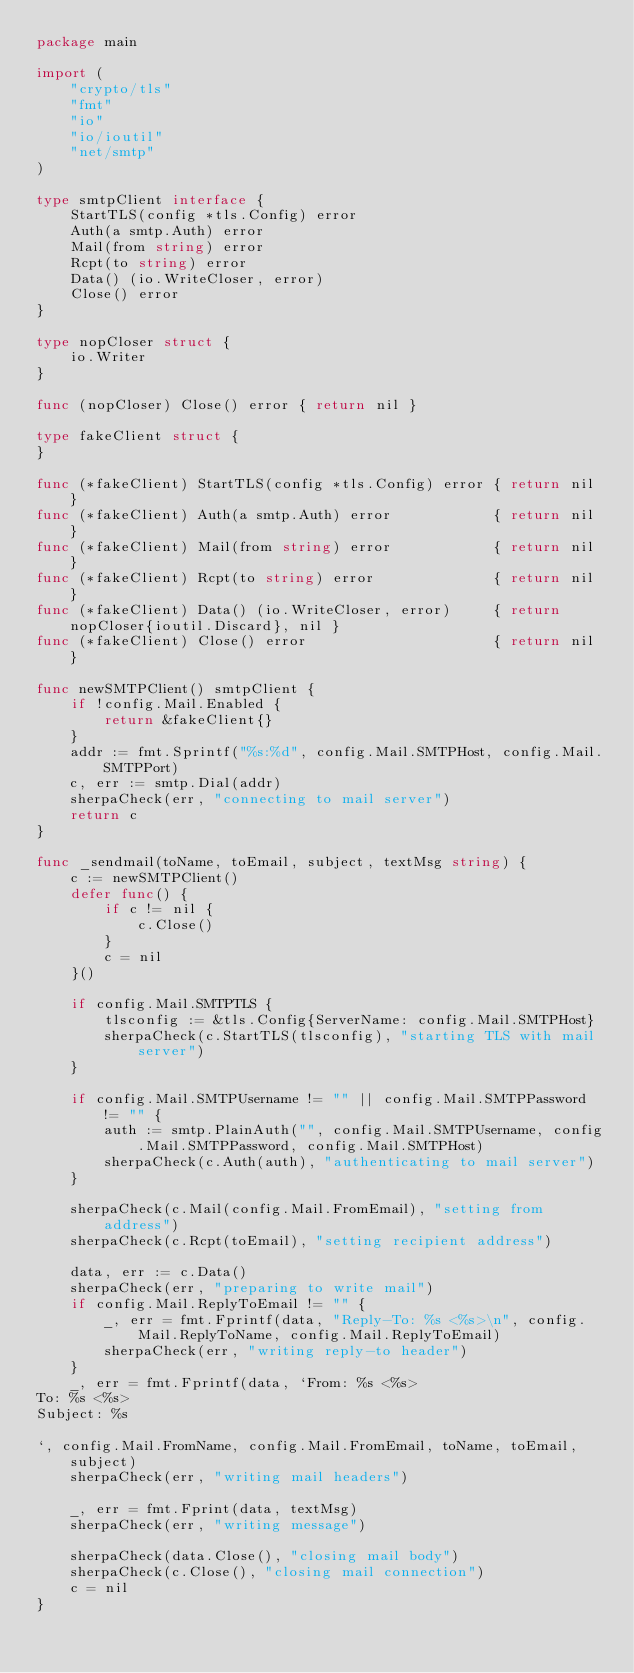Convert code to text. <code><loc_0><loc_0><loc_500><loc_500><_Go_>package main

import (
	"crypto/tls"
	"fmt"
	"io"
	"io/ioutil"
	"net/smtp"
)

type smtpClient interface {
	StartTLS(config *tls.Config) error
	Auth(a smtp.Auth) error
	Mail(from string) error
	Rcpt(to string) error
	Data() (io.WriteCloser, error)
	Close() error
}

type nopCloser struct {
	io.Writer
}

func (nopCloser) Close() error { return nil }

type fakeClient struct {
}

func (*fakeClient) StartTLS(config *tls.Config) error { return nil }
func (*fakeClient) Auth(a smtp.Auth) error            { return nil }
func (*fakeClient) Mail(from string) error            { return nil }
func (*fakeClient) Rcpt(to string) error              { return nil }
func (*fakeClient) Data() (io.WriteCloser, error)     { return nopCloser{ioutil.Discard}, nil }
func (*fakeClient) Close() error                      { return nil }

func newSMTPClient() smtpClient {
	if !config.Mail.Enabled {
		return &fakeClient{}
	}
	addr := fmt.Sprintf("%s:%d", config.Mail.SMTPHost, config.Mail.SMTPPort)
	c, err := smtp.Dial(addr)
	sherpaCheck(err, "connecting to mail server")
	return c
}

func _sendmail(toName, toEmail, subject, textMsg string) {
	c := newSMTPClient()
	defer func() {
		if c != nil {
			c.Close()
		}
		c = nil
	}()

	if config.Mail.SMTPTLS {
		tlsconfig := &tls.Config{ServerName: config.Mail.SMTPHost}
		sherpaCheck(c.StartTLS(tlsconfig), "starting TLS with mail server")
	}

	if config.Mail.SMTPUsername != "" || config.Mail.SMTPPassword != "" {
		auth := smtp.PlainAuth("", config.Mail.SMTPUsername, config.Mail.SMTPPassword, config.Mail.SMTPHost)
		sherpaCheck(c.Auth(auth), "authenticating to mail server")
	}

	sherpaCheck(c.Mail(config.Mail.FromEmail), "setting from address")
	sherpaCheck(c.Rcpt(toEmail), "setting recipient address")

	data, err := c.Data()
	sherpaCheck(err, "preparing to write mail")
	if config.Mail.ReplyToEmail != "" {
		_, err = fmt.Fprintf(data, "Reply-To: %s <%s>\n", config.Mail.ReplyToName, config.Mail.ReplyToEmail)
		sherpaCheck(err, "writing reply-to header")
	}
	_, err = fmt.Fprintf(data, `From: %s <%s>
To: %s <%s>
Subject: %s

`, config.Mail.FromName, config.Mail.FromEmail, toName, toEmail, subject)
	sherpaCheck(err, "writing mail headers")

	_, err = fmt.Fprint(data, textMsg)
	sherpaCheck(err, "writing message")

	sherpaCheck(data.Close(), "closing mail body")
	sherpaCheck(c.Close(), "closing mail connection")
	c = nil
}
</code> 